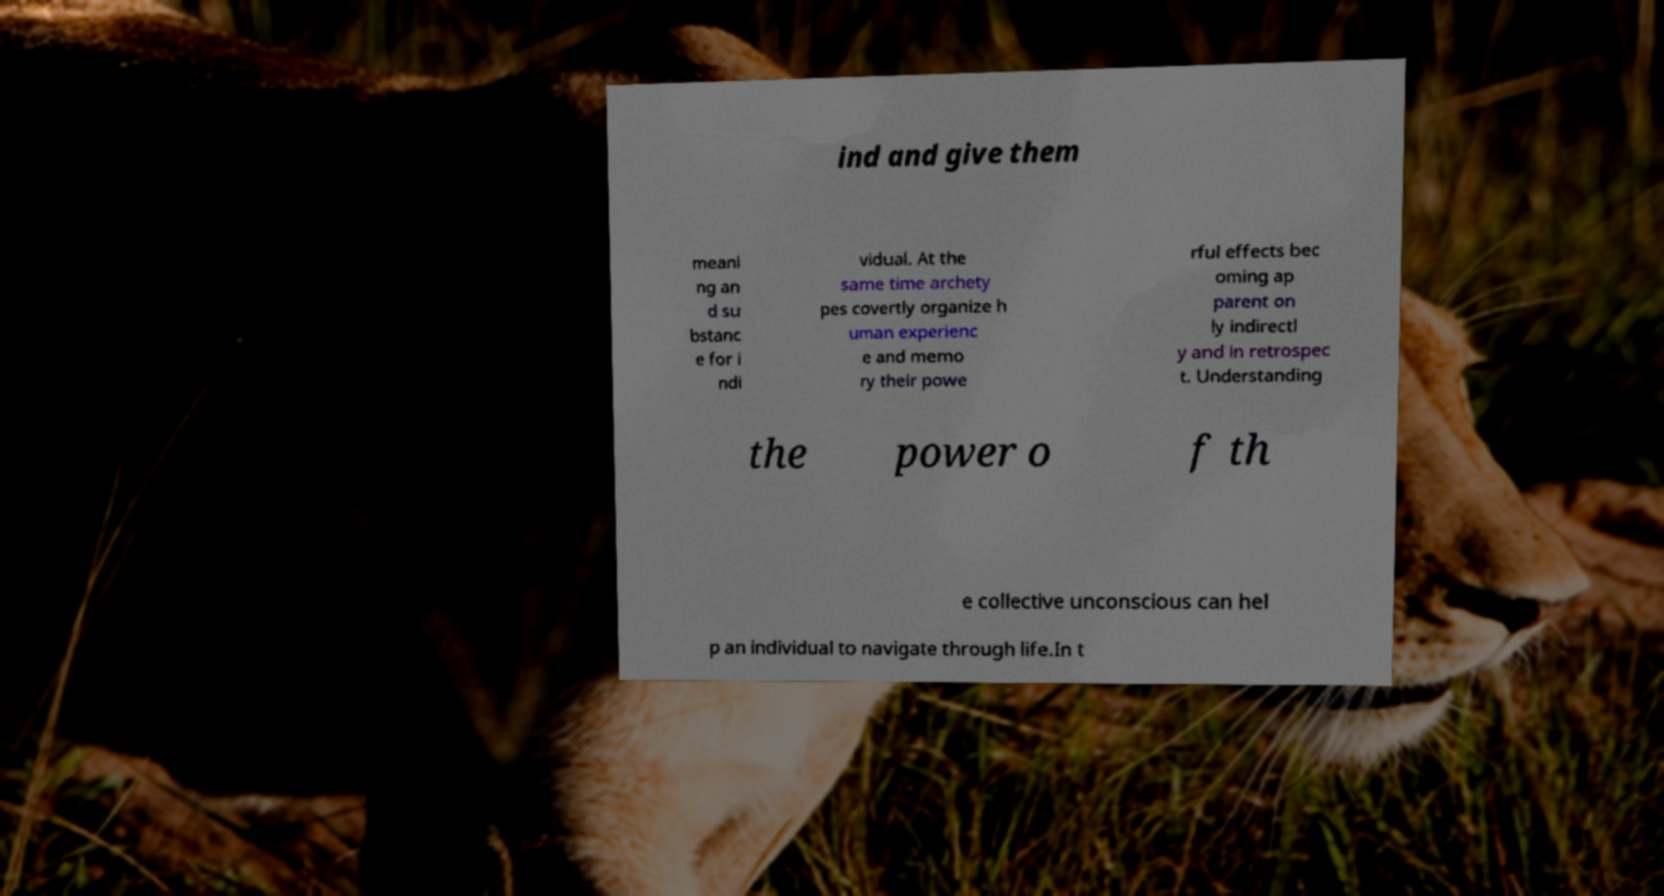For documentation purposes, I need the text within this image transcribed. Could you provide that? ind and give them meani ng an d su bstanc e for i ndi vidual. At the same time archety pes covertly organize h uman experienc e and memo ry their powe rful effects bec oming ap parent on ly indirectl y and in retrospec t. Understanding the power o f th e collective unconscious can hel p an individual to navigate through life.In t 